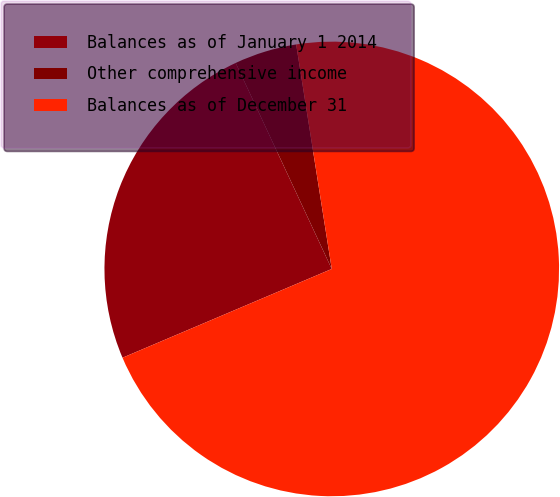<chart> <loc_0><loc_0><loc_500><loc_500><pie_chart><fcel>Balances as of January 1 2014<fcel>Other comprehensive income<fcel>Balances as of December 31<nl><fcel>24.44%<fcel>4.44%<fcel>71.11%<nl></chart> 